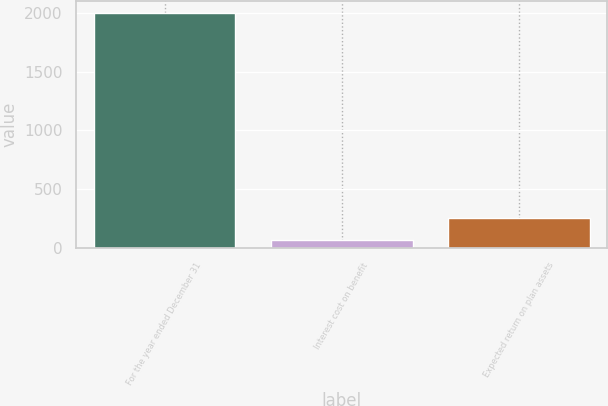Convert chart. <chart><loc_0><loc_0><loc_500><loc_500><bar_chart><fcel>For the year ended December 31<fcel>Interest cost on benefit<fcel>Expected return on plan assets<nl><fcel>2002<fcel>62<fcel>256<nl></chart> 